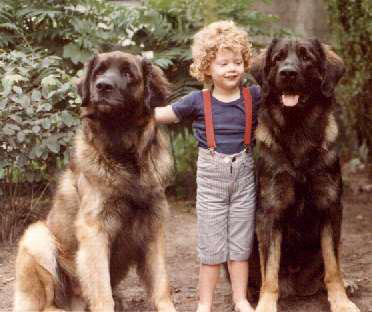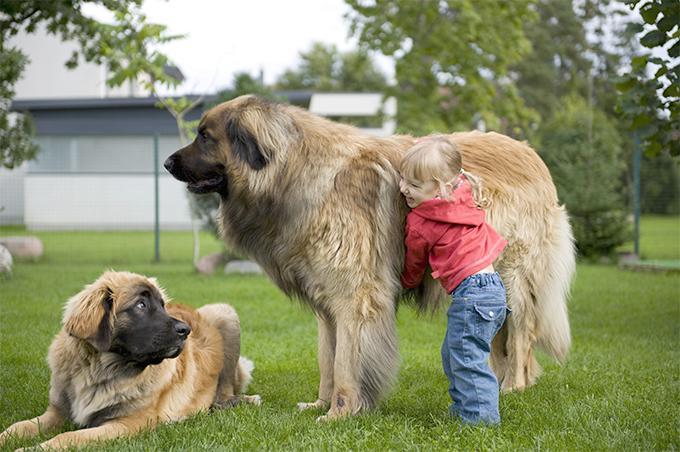The first image is the image on the left, the second image is the image on the right. Examine the images to the left and right. Is the description "There are exactly two dogs in the right image." accurate? Answer yes or no. Yes. The first image is the image on the left, the second image is the image on the right. For the images shown, is this caption "At least one person is petting a dog." true? Answer yes or no. Yes. 